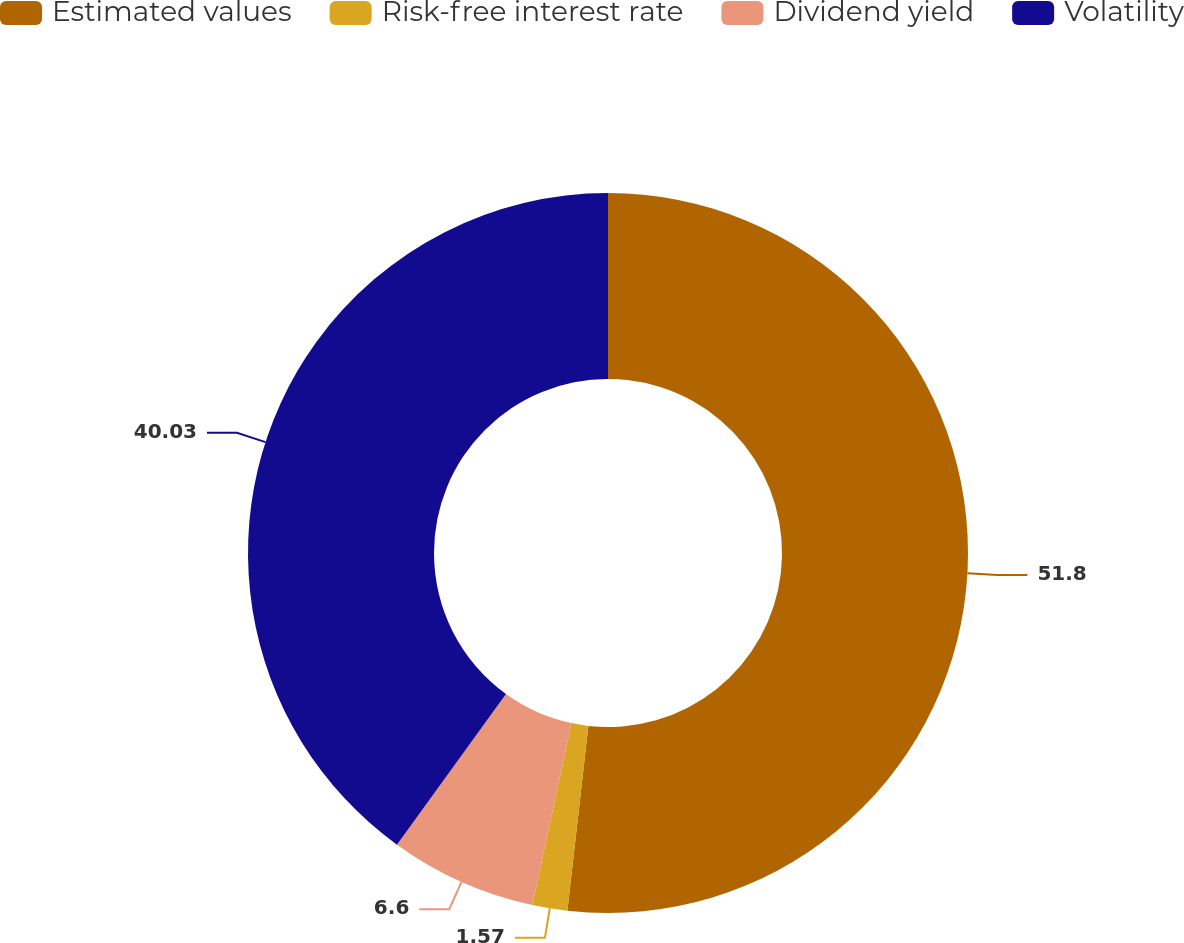Convert chart to OTSL. <chart><loc_0><loc_0><loc_500><loc_500><pie_chart><fcel>Estimated values<fcel>Risk-free interest rate<fcel>Dividend yield<fcel>Volatility<nl><fcel>51.8%<fcel>1.57%<fcel>6.6%<fcel>40.03%<nl></chart> 